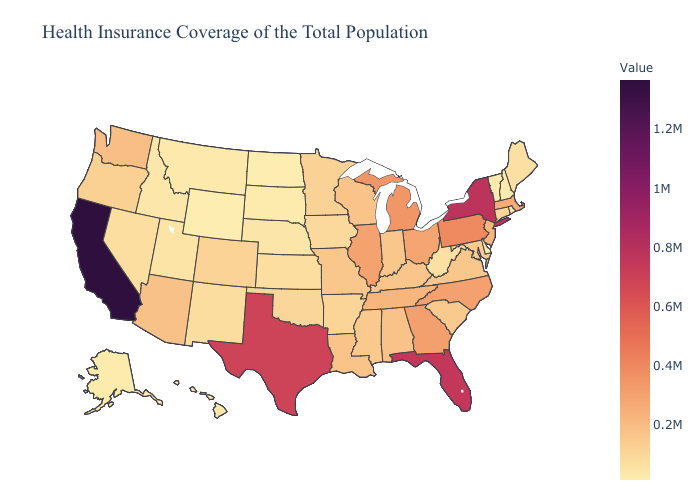Is the legend a continuous bar?
Concise answer only. Yes. Does the map have missing data?
Give a very brief answer. No. Does North Dakota have the lowest value in the USA?
Give a very brief answer. Yes. Does California have the highest value in the USA?
Answer briefly. Yes. Does Colorado have the lowest value in the USA?
Answer briefly. No. Does California have the lowest value in the USA?
Keep it brief. No. 